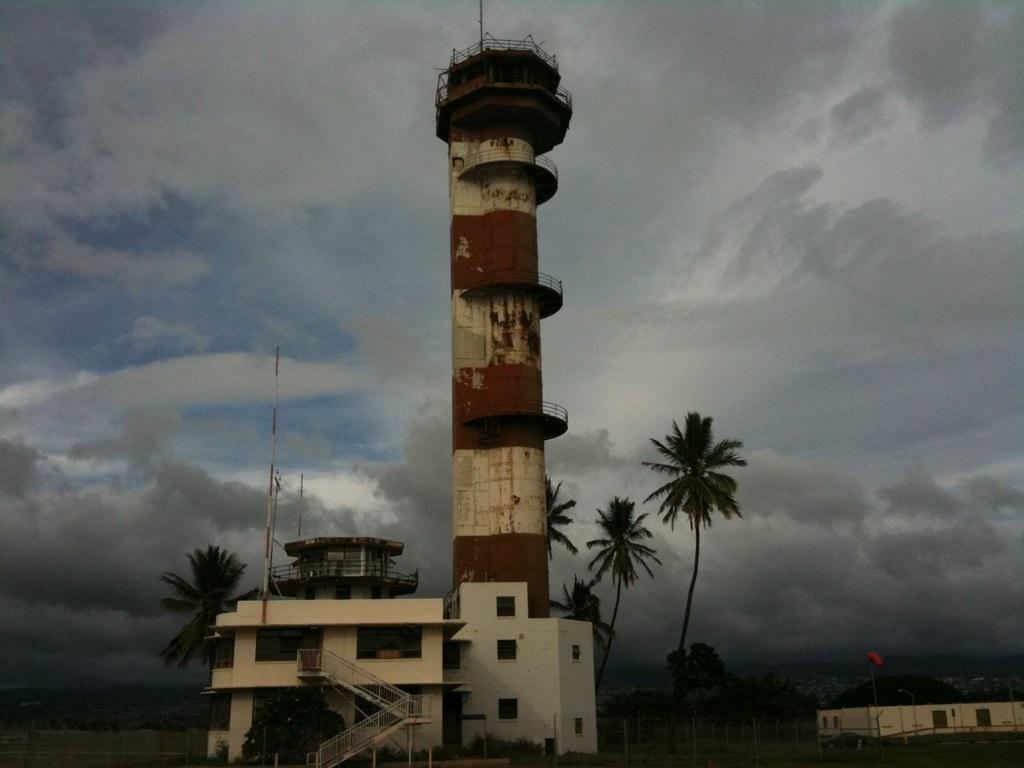Could you give a brief overview of what you see in this image? This image consists of buildings and a tower. Beside that, there are many trees. At the top, there are clouds in the sky. 